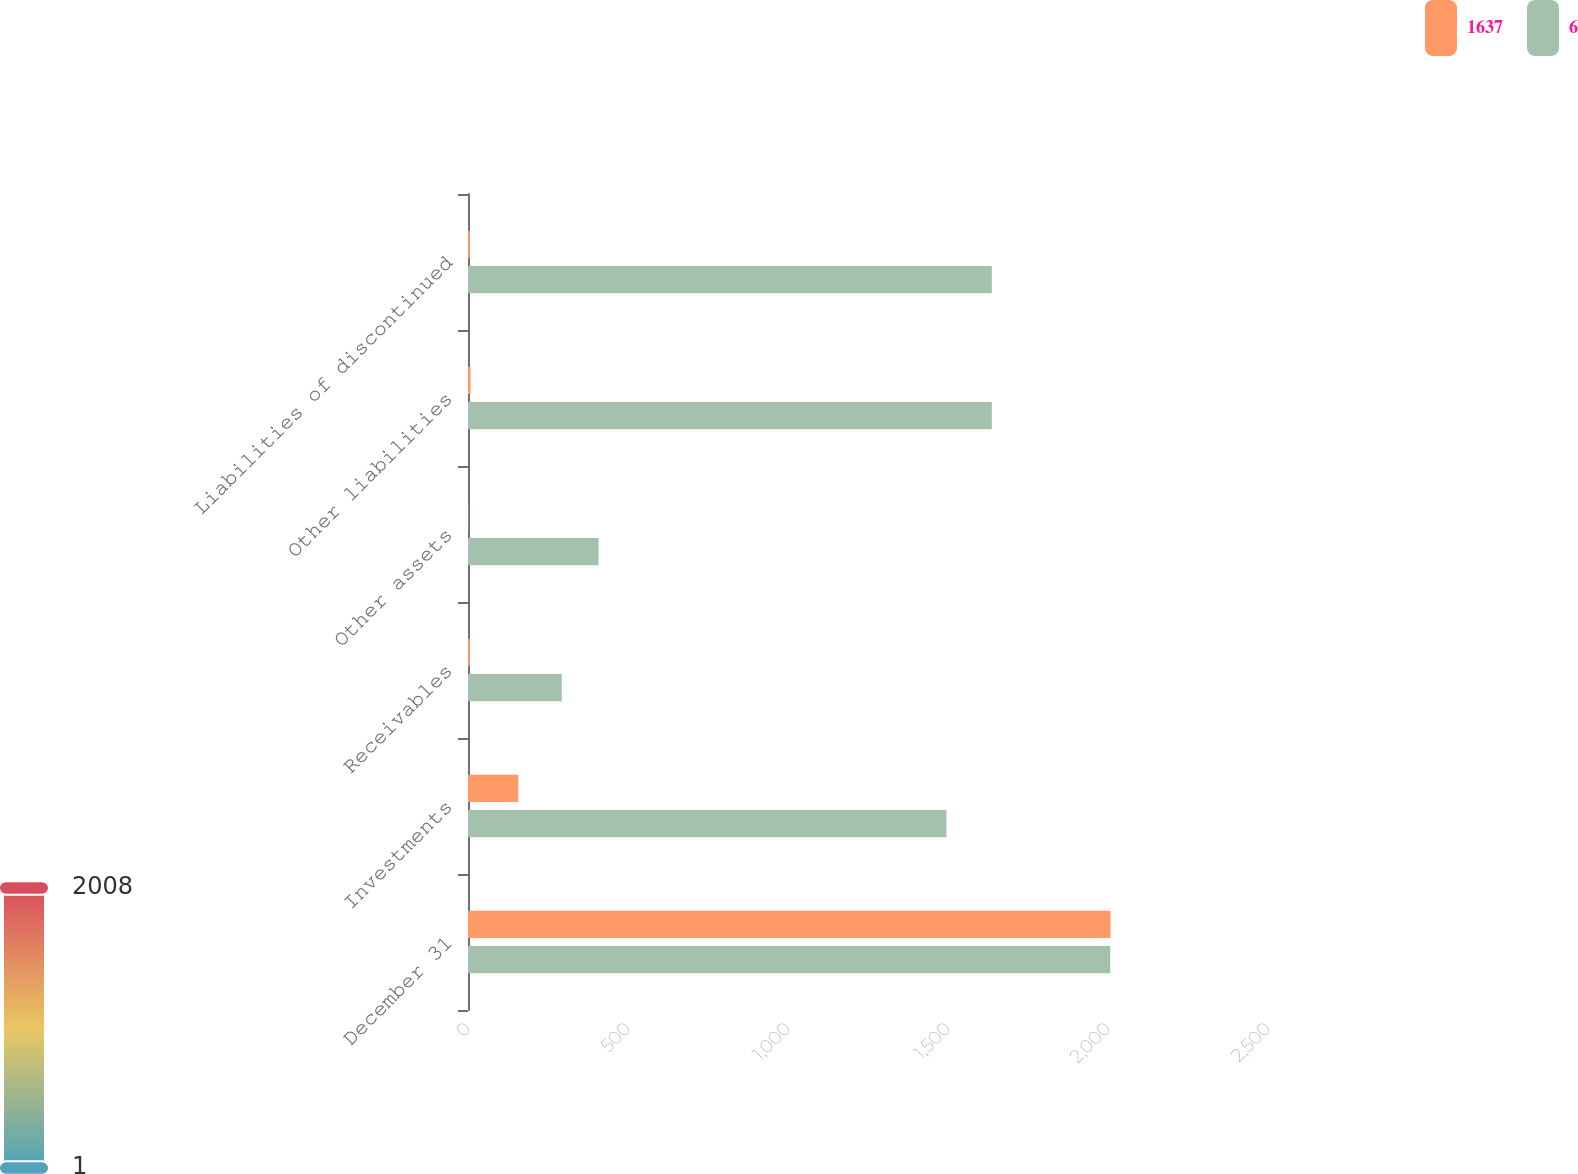Convert chart. <chart><loc_0><loc_0><loc_500><loc_500><stacked_bar_chart><ecel><fcel>December 31<fcel>Investments<fcel>Receivables<fcel>Other assets<fcel>Other liabilities<fcel>Liabilities of discontinued<nl><fcel>1637<fcel>2008<fcel>157<fcel>6<fcel>1<fcel>8<fcel>6<nl><fcel>6<fcel>2007<fcel>1495<fcel>293<fcel>408<fcel>1637<fcel>1637<nl></chart> 